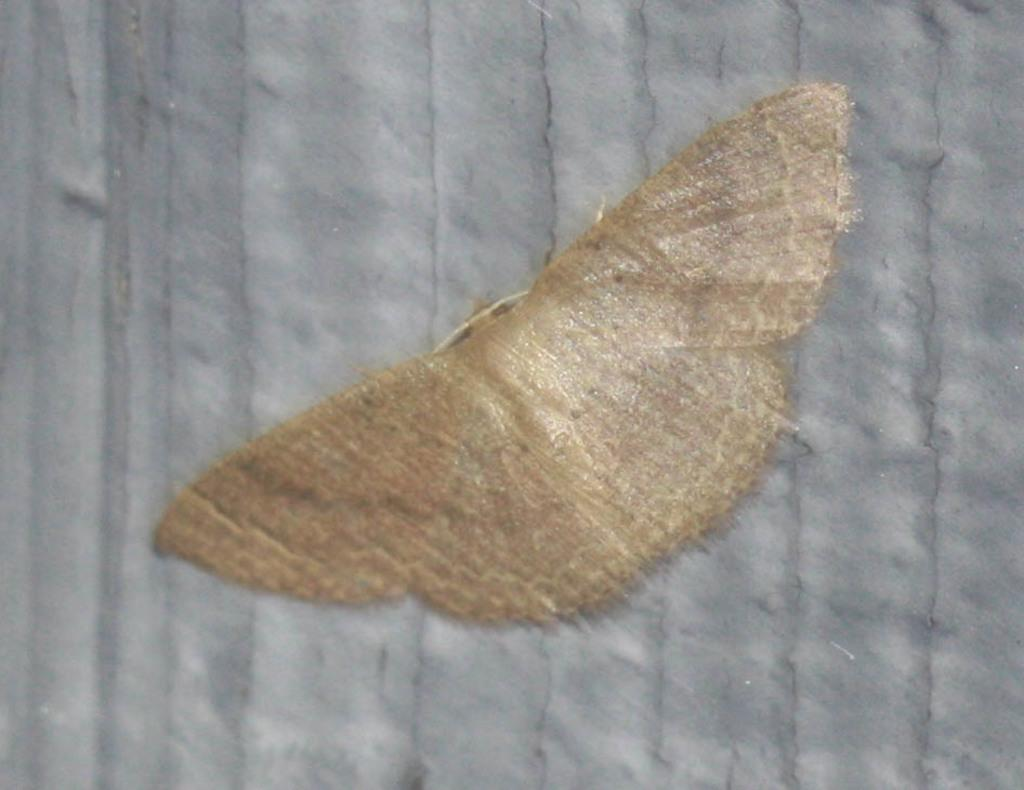What type of creature can be seen in the image? There is an insect in the image. Where is the insect located in the image? The insect is on the ground. What type of hat is the insect wearing in the image? There is no hat present in the image, as insects do not wear hats. 